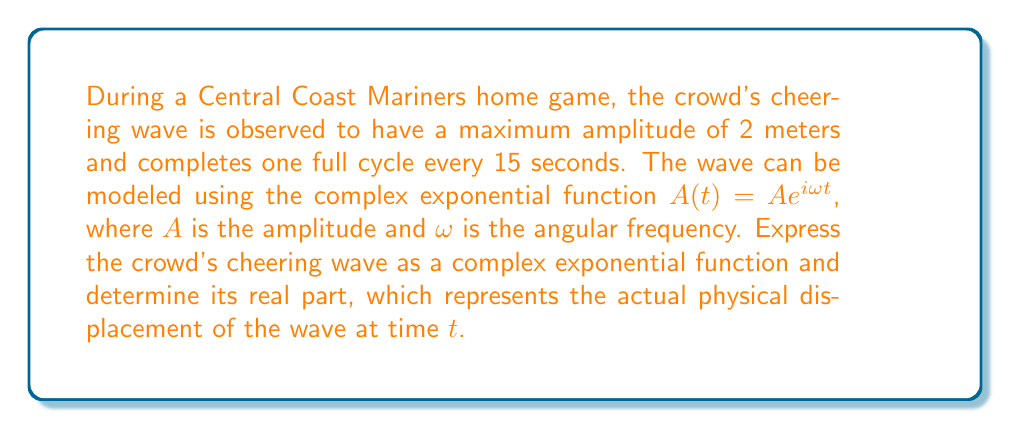Solve this math problem. To solve this problem, let's follow these steps:

1) First, we need to determine the angular frequency $\omega$. Given that the wave completes one full cycle every 15 seconds, the period $T$ is 15 seconds. The angular frequency is related to the period by:

   $\omega = \frac{2\pi}{T} = \frac{2\pi}{15}$ rad/s

2) We're given that the maximum amplitude $A$ is 2 meters.

3) Now we can express the wave as a complex exponential:

   $A(t) = 2e^{i\frac{2\pi}{15}t}$

4) To find the real part of this function, which represents the actual physical displacement, we use Euler's formula:

   $e^{ix} = \cos x + i \sin x$

5) Applying this to our function:

   $A(t) = 2e^{i\frac{2\pi}{15}t} = 2(\cos(\frac{2\pi}{15}t) + i\sin(\frac{2\pi}{15}t))$

6) The real part of this function is:

   $\text{Re}(A(t)) = 2\cos(\frac{2\pi}{15}t)$

This represents the actual physical displacement of the wave at time $t$.
Answer: The crowd's cheering wave can be expressed as the complex exponential function:

$A(t) = 2e^{i\frac{2\pi}{15}t}$

The real part, representing the actual physical displacement, is:

$\text{Re}(A(t)) = 2\cos(\frac{2\pi}{15}t)$ 